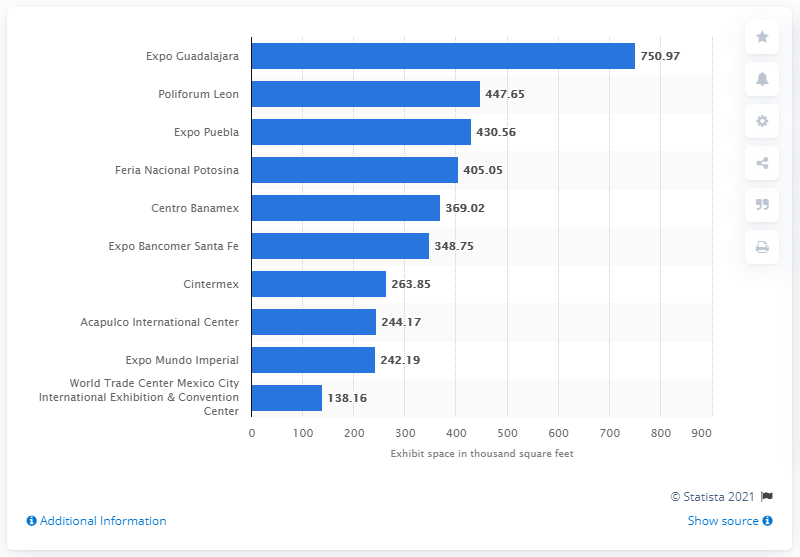Mention a couple of crucial points in this snapshot. Expo Guadalajara is the largest convention center in Mexico. Expo Guadalajara had approximately 750.97 square feet of exhibition space. 